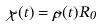<formula> <loc_0><loc_0><loc_500><loc_500>\tilde { \chi } ( t ) = \tilde { \rho } ( t ) R _ { 0 }</formula> 